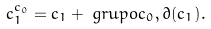<formula> <loc_0><loc_0><loc_500><loc_500>c _ { 1 } ^ { c _ { 0 } } & = c _ { 1 } + \ g r u p o { c _ { 0 } , \partial ( c _ { 1 } ) } .</formula> 